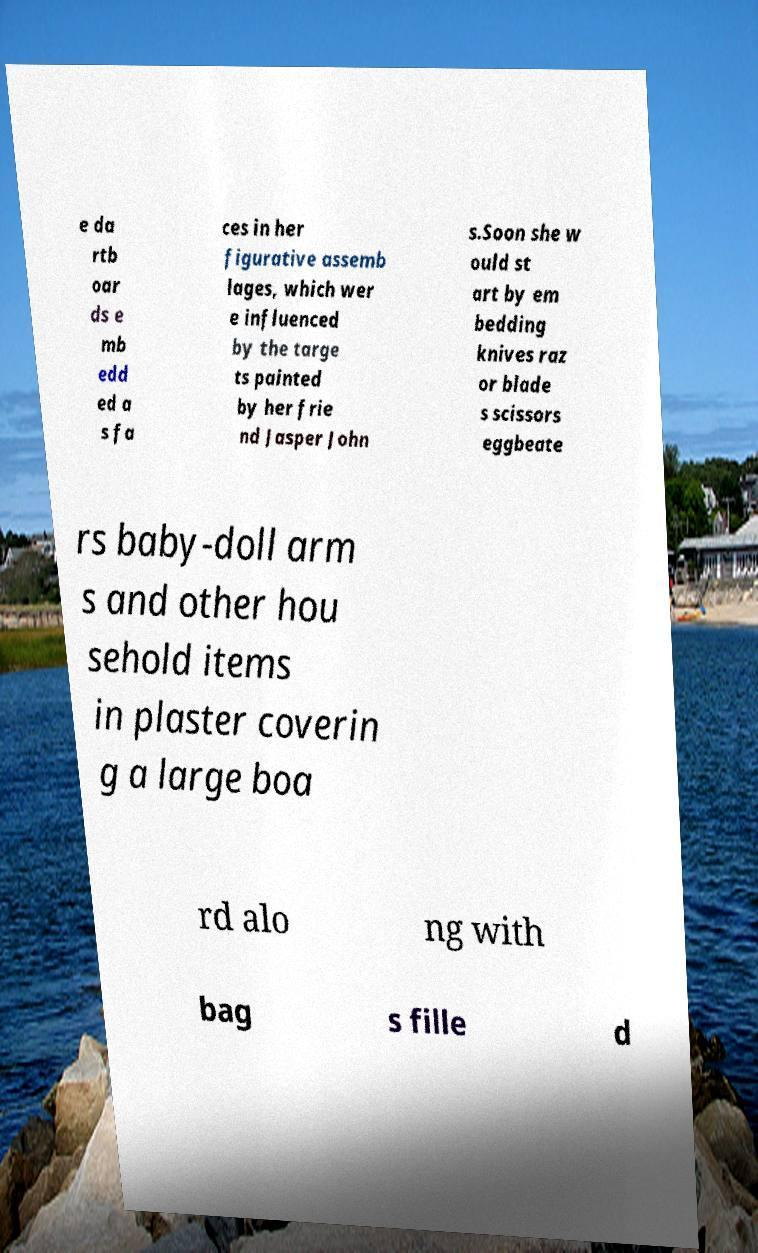Could you extract and type out the text from this image? e da rtb oar ds e mb edd ed a s fa ces in her figurative assemb lages, which wer e influenced by the targe ts painted by her frie nd Jasper John s.Soon she w ould st art by em bedding knives raz or blade s scissors eggbeate rs baby-doll arm s and other hou sehold items in plaster coverin g a large boa rd alo ng with bag s fille d 